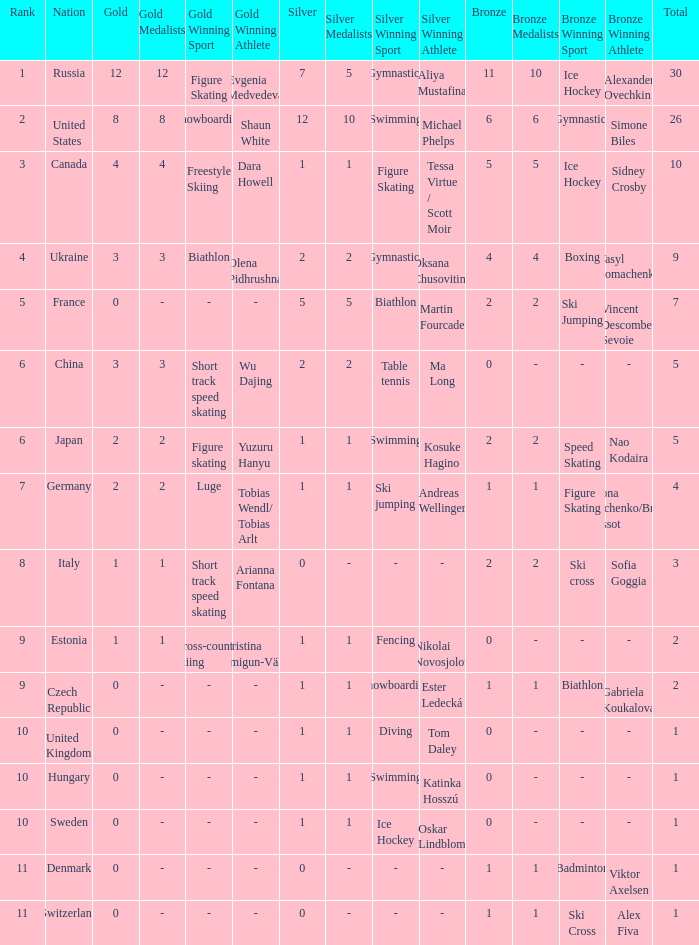How many silvers have a Nation of hungary, and a Rank larger than 10? 0.0. 